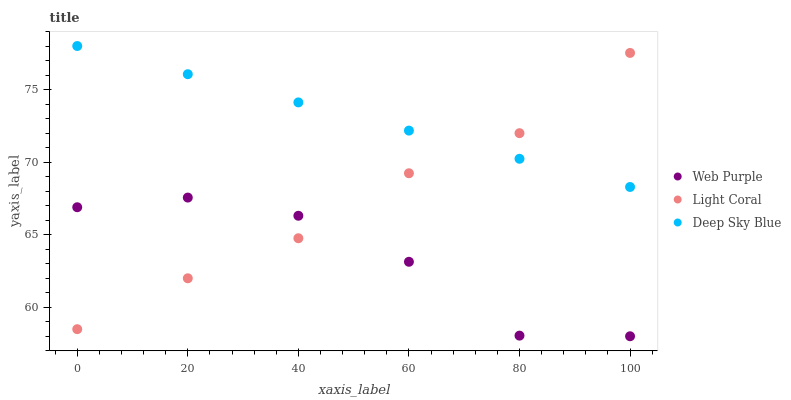Does Web Purple have the minimum area under the curve?
Answer yes or no. Yes. Does Deep Sky Blue have the maximum area under the curve?
Answer yes or no. Yes. Does Deep Sky Blue have the minimum area under the curve?
Answer yes or no. No. Does Web Purple have the maximum area under the curve?
Answer yes or no. No. Is Deep Sky Blue the smoothest?
Answer yes or no. Yes. Is Web Purple the roughest?
Answer yes or no. Yes. Is Web Purple the smoothest?
Answer yes or no. No. Is Deep Sky Blue the roughest?
Answer yes or no. No. Does Web Purple have the lowest value?
Answer yes or no. Yes. Does Deep Sky Blue have the lowest value?
Answer yes or no. No. Does Deep Sky Blue have the highest value?
Answer yes or no. Yes. Does Web Purple have the highest value?
Answer yes or no. No. Is Web Purple less than Deep Sky Blue?
Answer yes or no. Yes. Is Deep Sky Blue greater than Web Purple?
Answer yes or no. Yes. Does Deep Sky Blue intersect Light Coral?
Answer yes or no. Yes. Is Deep Sky Blue less than Light Coral?
Answer yes or no. No. Is Deep Sky Blue greater than Light Coral?
Answer yes or no. No. Does Web Purple intersect Deep Sky Blue?
Answer yes or no. No. 